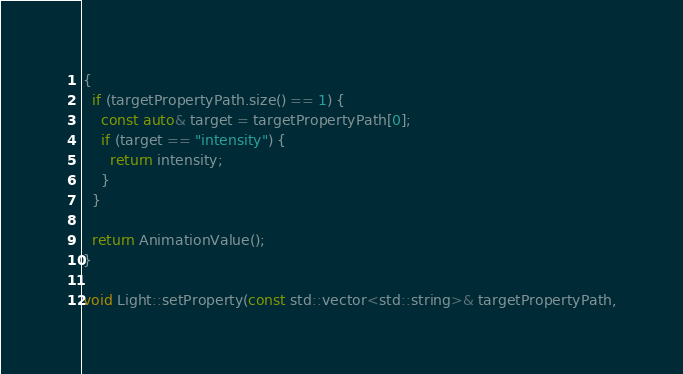Convert code to text. <code><loc_0><loc_0><loc_500><loc_500><_C++_>{
  if (targetPropertyPath.size() == 1) {
    const auto& target = targetPropertyPath[0];
    if (target == "intensity") {
      return intensity;
    }
  }

  return AnimationValue();
}

void Light::setProperty(const std::vector<std::string>& targetPropertyPath,</code> 